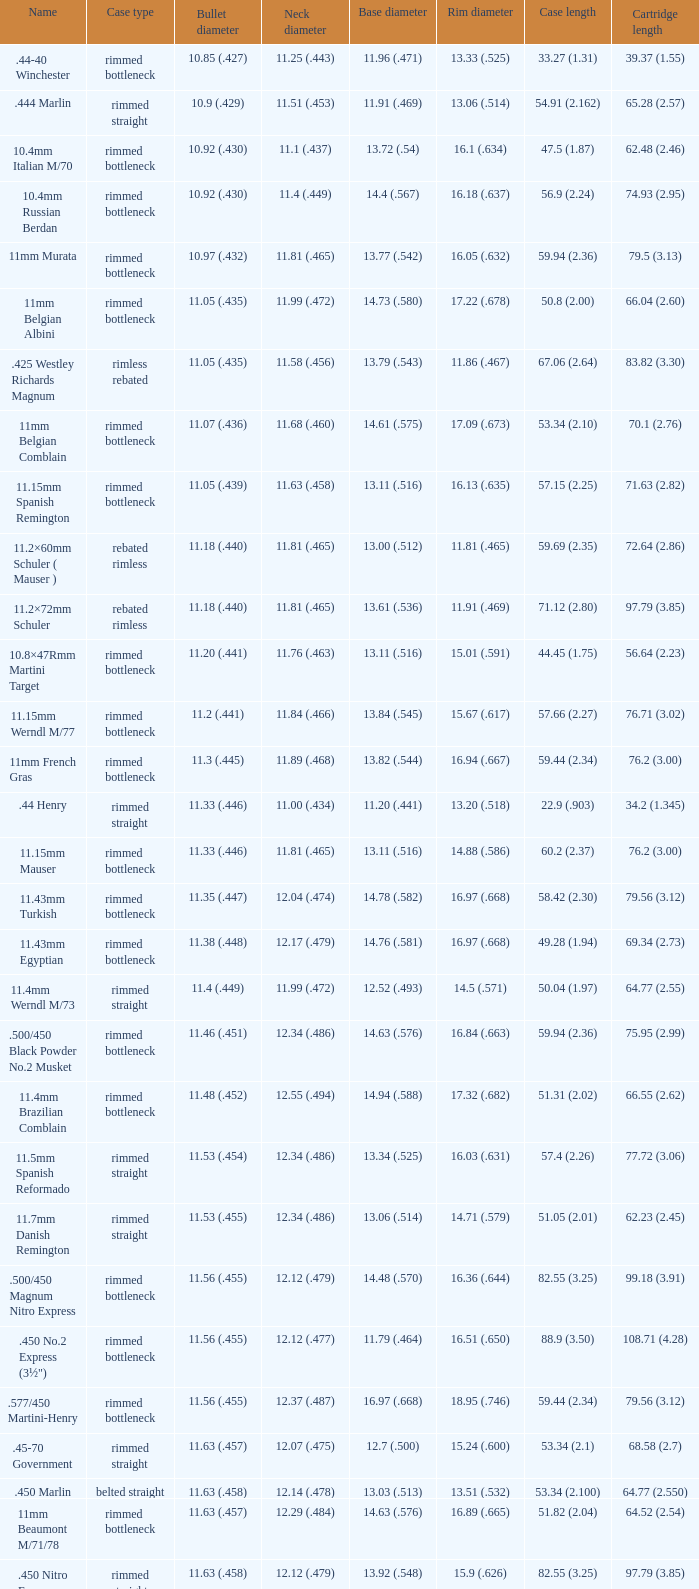Which Case length has a Rim diameter of 13.20 (.518)? 22.9 (.903). 